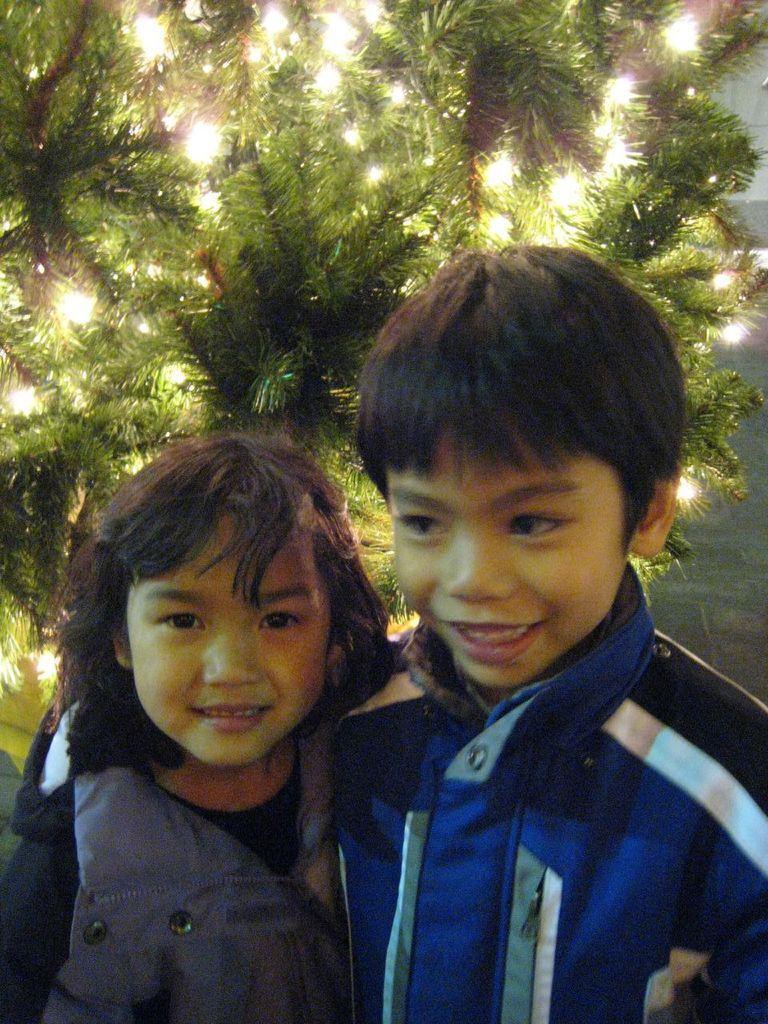How would you summarize this image in a sentence or two? In this image I can see two people are wearing different color dresses. I can see the christmas tree and few lights to it. 